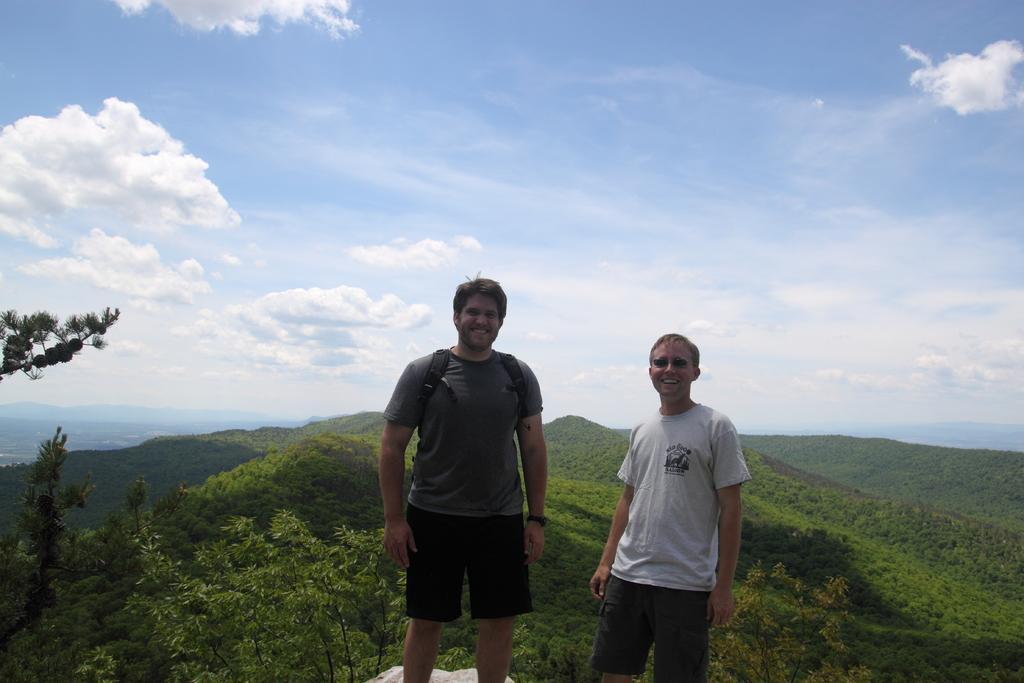How would you summarize this image in a sentence or two? In this image I can see two people standing and one person is wearing a bag. Back I can see few trees and mountains. The sky is in blue and white color. 